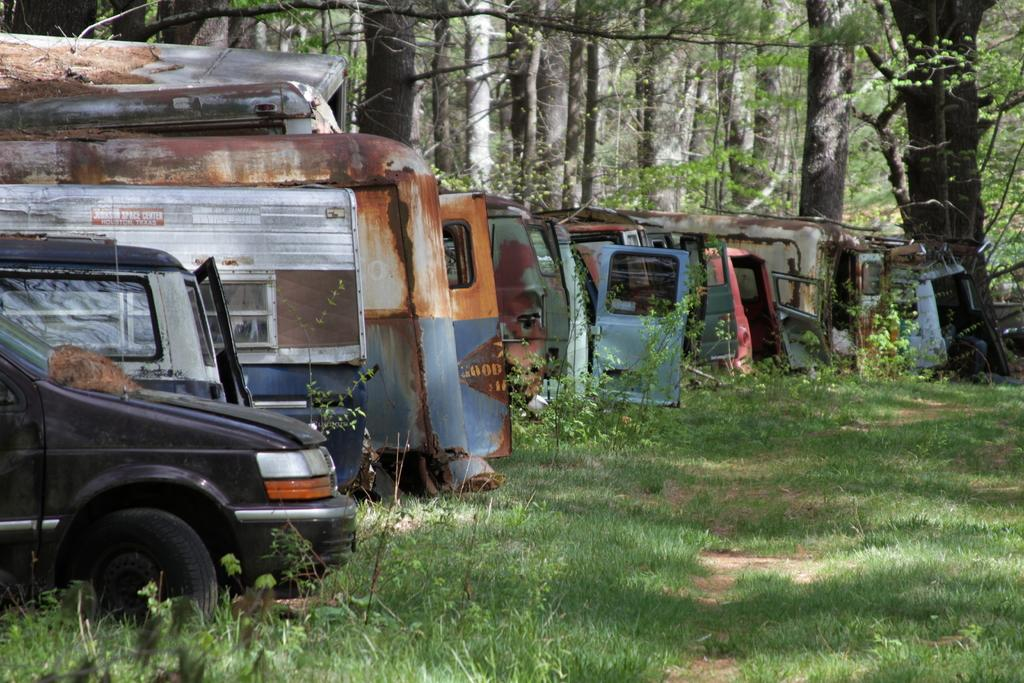What type of natural environment is visible in the image? There is grass and trees visible in the image. What else can be seen in the image besides the natural environment? There are vehicles in the image. What type of friction can be observed between the vehicles in the image? There is no indication of friction between the vehicles in the image, as the image does not depict any movement or interaction between them. Can you describe the flight patterns of the birds in the image? There are no birds present in the image, so it is not possible to describe their flight patterns. 